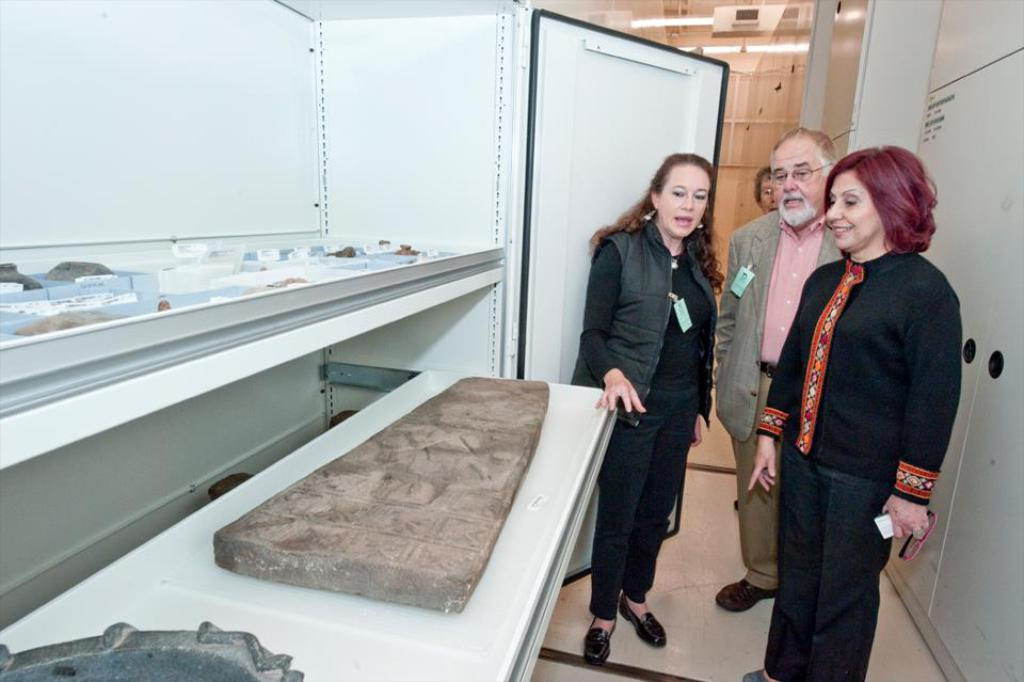How many people are standing on the right side of the image? There are four persons standing on the right side of the image. What can be found on the left side of the image? There is a stone on the left side of the image. What is visible at the top of the image? There are lights visible at the top of the image. Can you tell me where the sun is located in the image? There is no mention of the sun in the image, so we cannot determine its location. Is there a toad visible in the image? There is no mention of a toad in the image, so we cannot determine if it is present. 